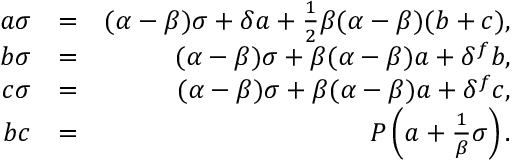<formula> <loc_0><loc_0><loc_500><loc_500>\begin{array} { r l r } { a \sigma } & { = } & { ( \alpha - \beta ) \sigma + \delta a + \frac { 1 } { 2 } \beta ( \alpha - \beta ) ( b + c ) , } \\ { b \sigma } & { = } & { ( \alpha - \beta ) \sigma + \beta ( \alpha - \beta ) a + \delta ^ { f } b , } \\ { c \sigma } & { = } & { ( \alpha - \beta ) \sigma + \beta ( \alpha - \beta ) a + \delta ^ { f } c , } \\ { b c } & { = } & { P \left ( a + \frac { 1 } { \beta } \sigma \right ) . } \end{array}</formula> 